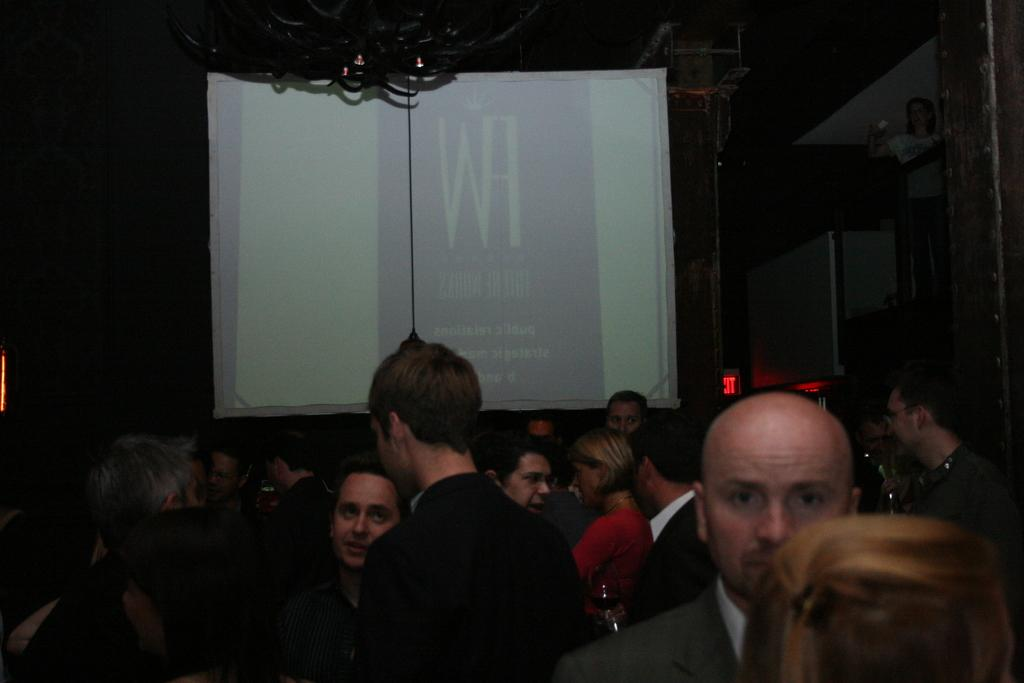What is located in the foreground of the image? There are people in the foreground of the image. What can be seen in the middle of the image? There is a screen in the middle of the image. Can you describe the object at the top of the image? Unfortunately, the facts provided do not give any information about the object at the top of the image. How many units are resting in the harbor in the image? There is no harbor or units present in the image. What type of rest can be seen being taken by the people in the image? The facts provided do not give any information about the people resting or taking a break in the image. 